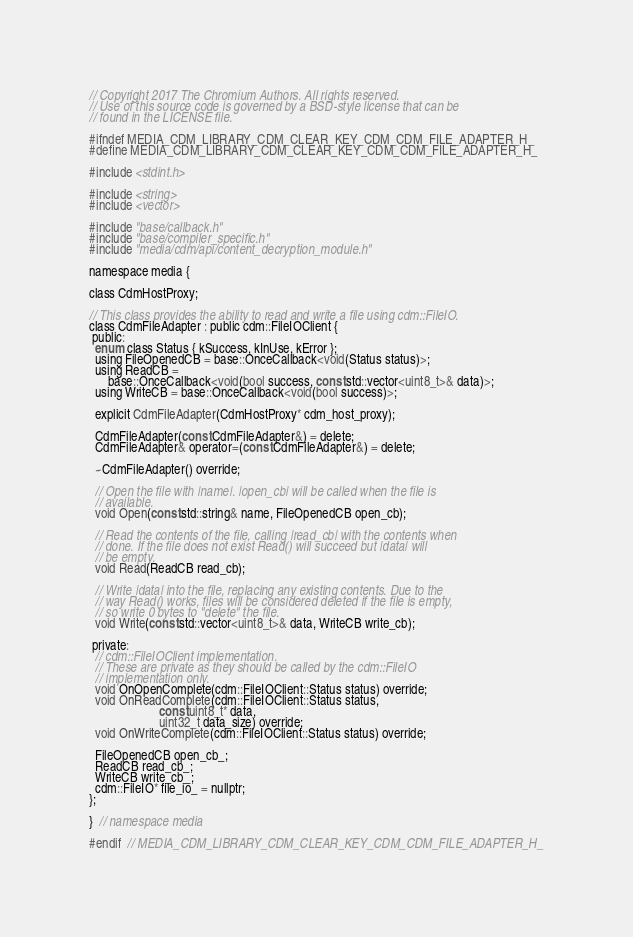<code> <loc_0><loc_0><loc_500><loc_500><_C_>// Copyright 2017 The Chromium Authors. All rights reserved.
// Use of this source code is governed by a BSD-style license that can be
// found in the LICENSE file.

#ifndef MEDIA_CDM_LIBRARY_CDM_CLEAR_KEY_CDM_CDM_FILE_ADAPTER_H_
#define MEDIA_CDM_LIBRARY_CDM_CLEAR_KEY_CDM_CDM_FILE_ADAPTER_H_

#include <stdint.h>

#include <string>
#include <vector>

#include "base/callback.h"
#include "base/compiler_specific.h"
#include "media/cdm/api/content_decryption_module.h"

namespace media {

class CdmHostProxy;

// This class provides the ability to read and write a file using cdm::FileIO.
class CdmFileAdapter : public cdm::FileIOClient {
 public:
  enum class Status { kSuccess, kInUse, kError };
  using FileOpenedCB = base::OnceCallback<void(Status status)>;
  using ReadCB =
      base::OnceCallback<void(bool success, const std::vector<uint8_t>& data)>;
  using WriteCB = base::OnceCallback<void(bool success)>;

  explicit CdmFileAdapter(CdmHostProxy* cdm_host_proxy);

  CdmFileAdapter(const CdmFileAdapter&) = delete;
  CdmFileAdapter& operator=(const CdmFileAdapter&) = delete;

  ~CdmFileAdapter() override;

  // Open the file with |name|. |open_cb| will be called when the file is
  // available.
  void Open(const std::string& name, FileOpenedCB open_cb);

  // Read the contents of the file, calling |read_cb| with the contents when
  // done. If the file does not exist Read() will succeed but |data| will
  // be empty.
  void Read(ReadCB read_cb);

  // Write |data| into the file, replacing any existing contents. Due to the
  // way Read() works, files will be considered deleted if the file is empty,
  // so write 0 bytes to "delete" the file.
  void Write(const std::vector<uint8_t>& data, WriteCB write_cb);

 private:
  // cdm::FileIOClient implementation.
  // These are private as they should be called by the cdm::FileIO
  // implementation only.
  void OnOpenComplete(cdm::FileIOClient::Status status) override;
  void OnReadComplete(cdm::FileIOClient::Status status,
                      const uint8_t* data,
                      uint32_t data_size) override;
  void OnWriteComplete(cdm::FileIOClient::Status status) override;

  FileOpenedCB open_cb_;
  ReadCB read_cb_;
  WriteCB write_cb_;
  cdm::FileIO* file_io_ = nullptr;
};

}  // namespace media

#endif  // MEDIA_CDM_LIBRARY_CDM_CLEAR_KEY_CDM_CDM_FILE_ADAPTER_H_
</code> 